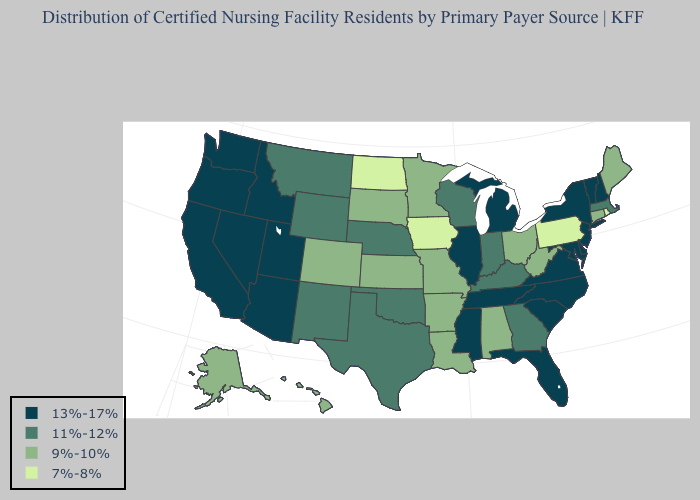Among the states that border California , which have the highest value?
Short answer required. Arizona, Nevada, Oregon. Name the states that have a value in the range 7%-8%?
Short answer required. Iowa, North Dakota, Pennsylvania, Rhode Island. What is the value of Kentucky?
Quick response, please. 11%-12%. Name the states that have a value in the range 9%-10%?
Keep it brief. Alabama, Alaska, Arkansas, Colorado, Connecticut, Hawaii, Kansas, Louisiana, Maine, Minnesota, Missouri, Ohio, South Dakota, West Virginia. What is the value of Georgia?
Answer briefly. 11%-12%. What is the highest value in states that border Connecticut?
Quick response, please. 13%-17%. Does Arkansas have the lowest value in the South?
Concise answer only. Yes. Which states have the lowest value in the USA?
Be succinct. Iowa, North Dakota, Pennsylvania, Rhode Island. What is the highest value in states that border Maine?
Write a very short answer. 13%-17%. Does Alabama have the lowest value in the South?
Answer briefly. Yes. What is the value of Nevada?
Short answer required. 13%-17%. What is the highest value in the Northeast ?
Write a very short answer. 13%-17%. Name the states that have a value in the range 13%-17%?
Keep it brief. Arizona, California, Delaware, Florida, Idaho, Illinois, Maryland, Michigan, Mississippi, Nevada, New Hampshire, New Jersey, New York, North Carolina, Oregon, South Carolina, Tennessee, Utah, Vermont, Virginia, Washington. Does Vermont have the highest value in the USA?
Give a very brief answer. Yes. What is the lowest value in states that border Missouri?
Write a very short answer. 7%-8%. 